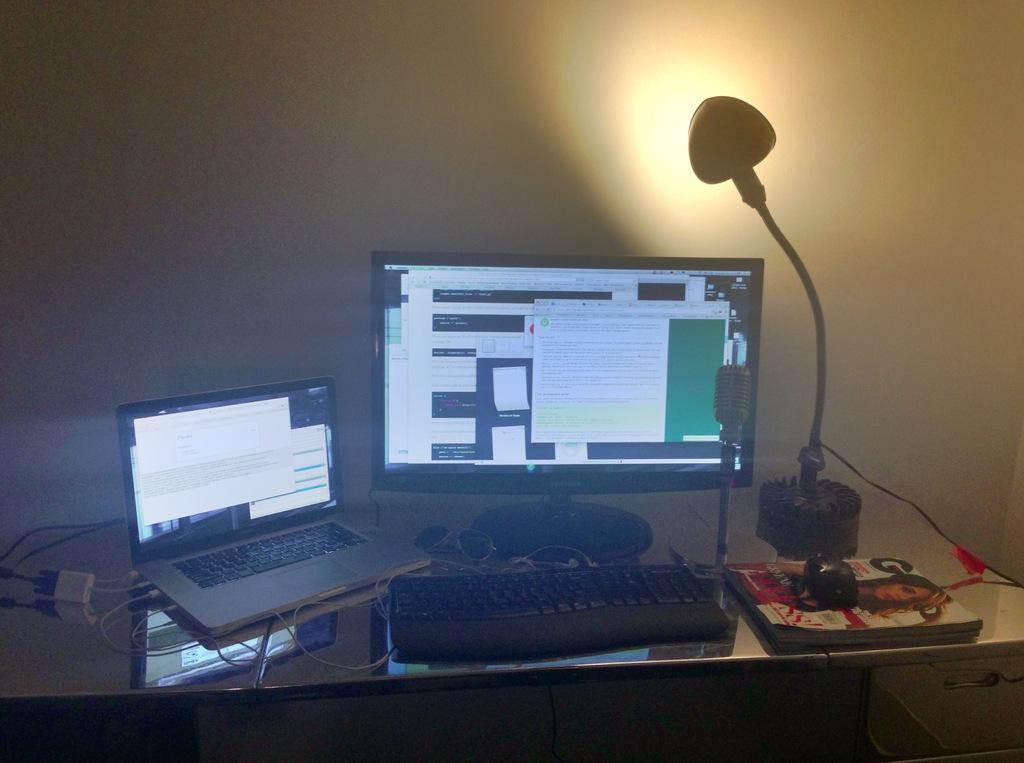<image>
Create a compact narrative representing the image presented. A GQ magazine sits next to a laptop and a desktop computer. 